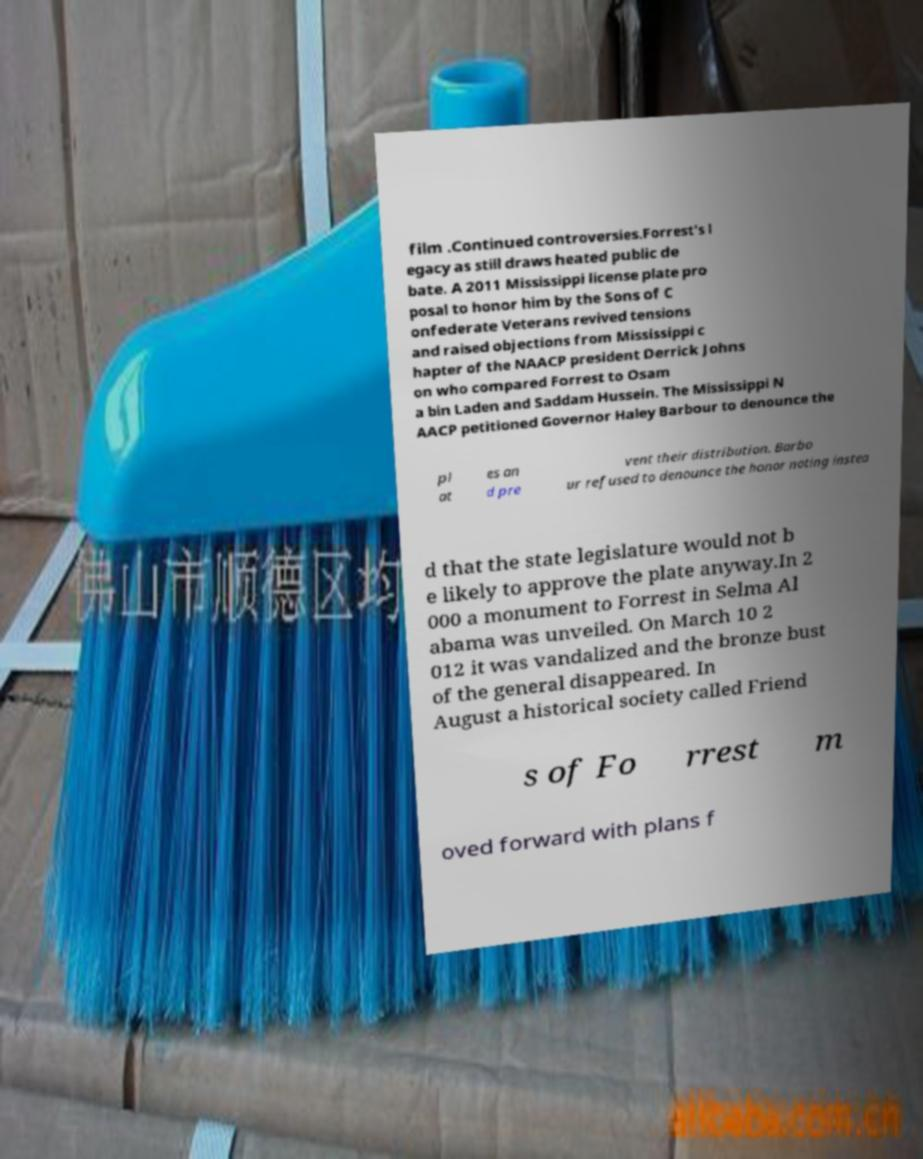Can you accurately transcribe the text from the provided image for me? film .Continued controversies.Forrest's l egacy as still draws heated public de bate. A 2011 Mississippi license plate pro posal to honor him by the Sons of C onfederate Veterans revived tensions and raised objections from Mississippi c hapter of the NAACP president Derrick Johns on who compared Forrest to Osam a bin Laden and Saddam Hussein. The Mississippi N AACP petitioned Governor Haley Barbour to denounce the pl at es an d pre vent their distribution. Barbo ur refused to denounce the honor noting instea d that the state legislature would not b e likely to approve the plate anyway.In 2 000 a monument to Forrest in Selma Al abama was unveiled. On March 10 2 012 it was vandalized and the bronze bust of the general disappeared. In August a historical society called Friend s of Fo rrest m oved forward with plans f 